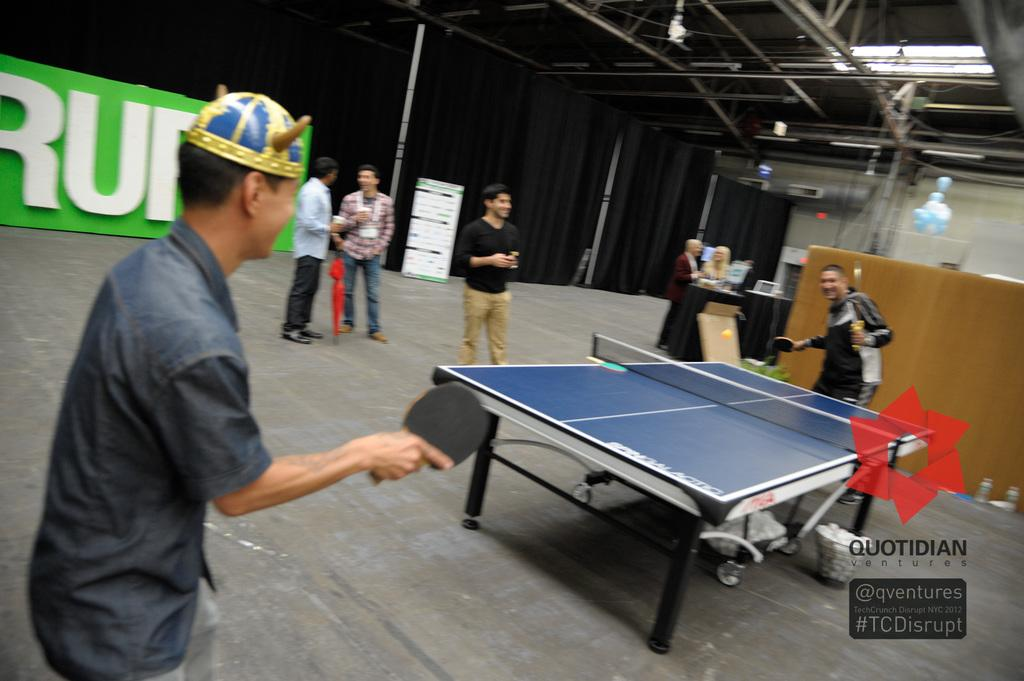What is happening in the room in the image? There are people in the room, and some of them are playing a game. Can you describe the position of at least one person in the room? There is at least one person standing on the floor. What is the color of the background in the image? The background of the image is black. Can you tell me how many snails are crawling on the floor in the image? There are no snails present in the image; it features people in a room. What type of soda is being served in the image? There is no soda visible in the image. 